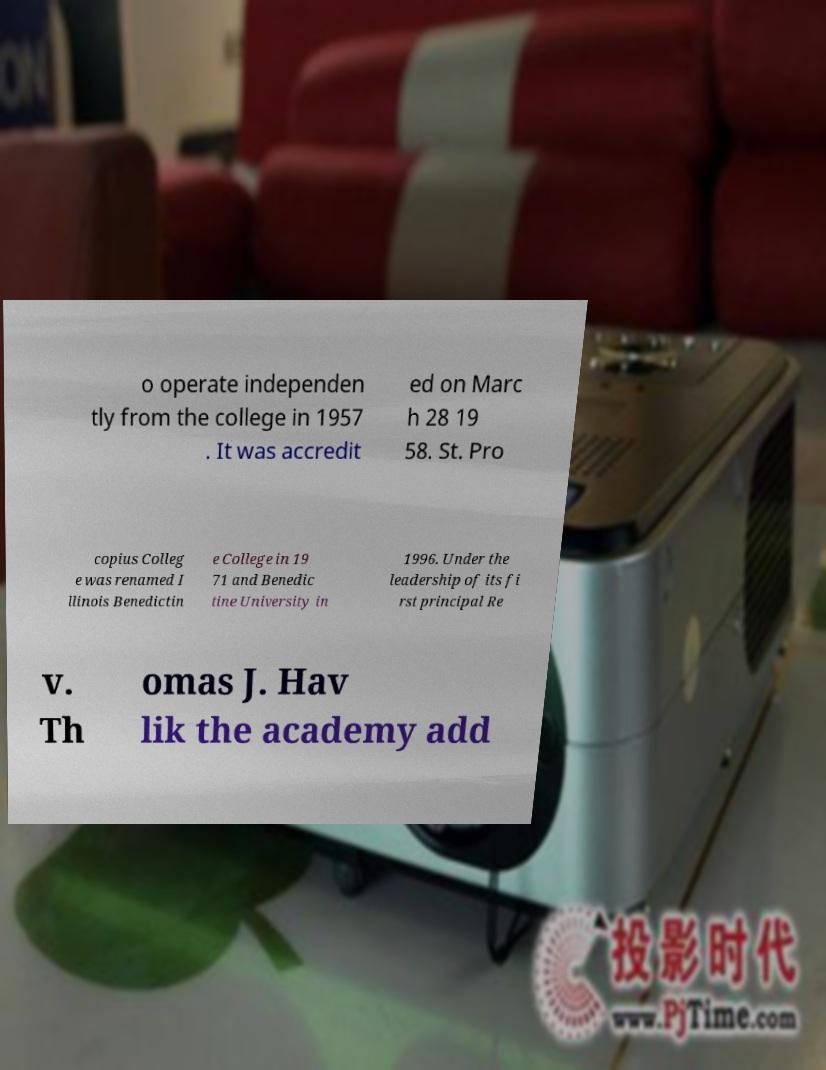Could you extract and type out the text from this image? o operate independen tly from the college in 1957 . It was accredit ed on Marc h 28 19 58. St. Pro copius Colleg e was renamed I llinois Benedictin e College in 19 71 and Benedic tine University in 1996. Under the leadership of its fi rst principal Re v. Th omas J. Hav lik the academy add 